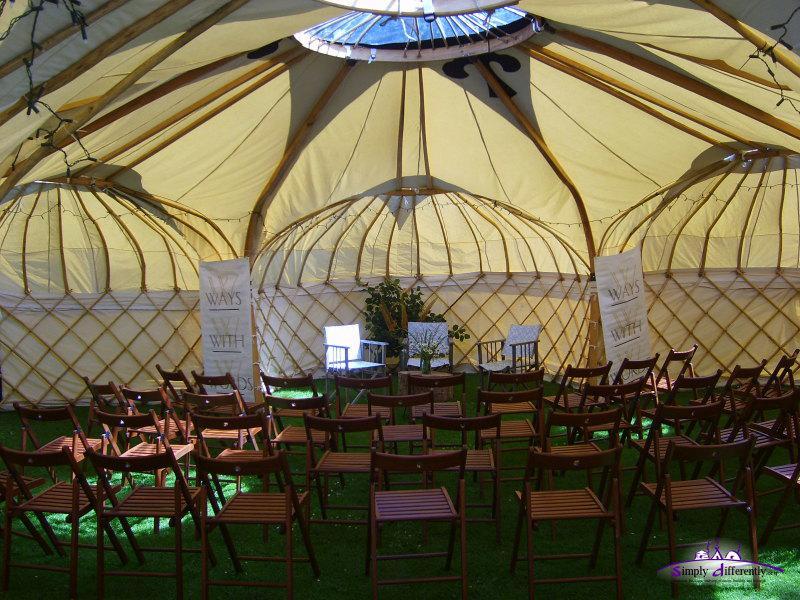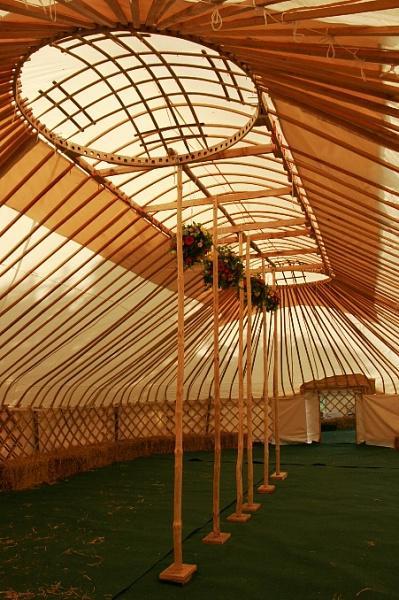The first image is the image on the left, the second image is the image on the right. For the images displayed, is the sentence "An image shows an interior with three side-by-side lattice-work dome-topped structural elements visible." factually correct? Answer yes or no. Yes. The first image is the image on the left, the second image is the image on the right. Considering the images on both sides, is "One image shows the interior of a large yurt with the framework of three small side-by-side yurts in the rear and a skylight overhead." valid? Answer yes or no. Yes. 